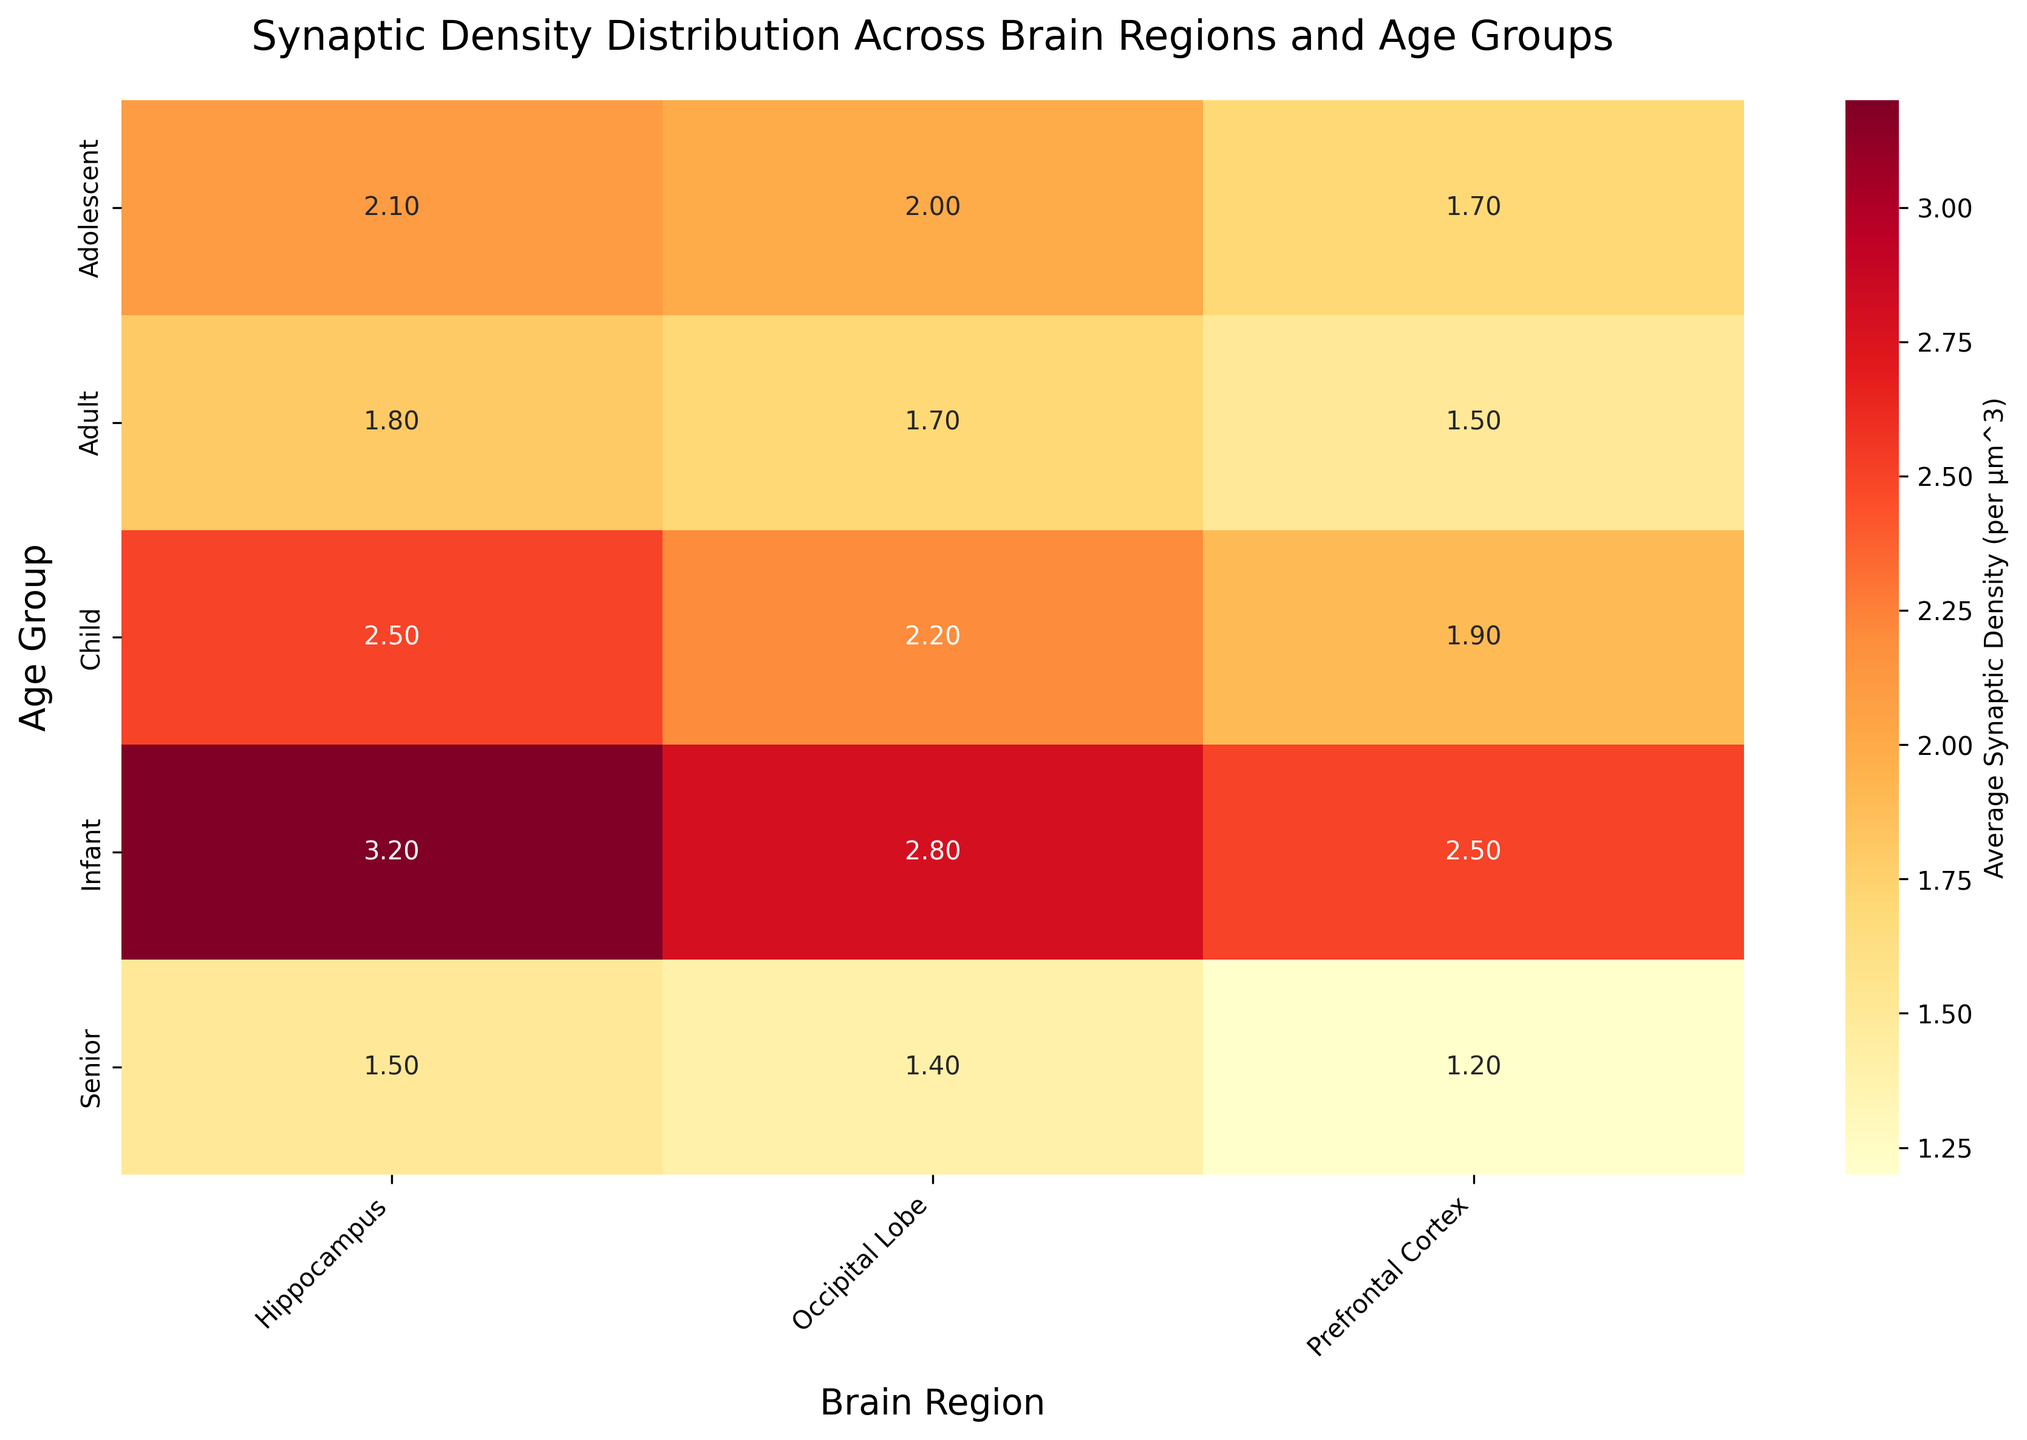What age group and brain region have the highest average synaptic density? The heatmap shows the average synaptic densities across different brain regions and age groups. The cell with the brightest color in the heatmap corresponds to the highest value. By examining the figure, we see that the brightest cell is in the Infant age group and Hippocampus region, indicating the highest average synaptic density.
Answer: Infant in the Hippocampus What is the title of the heatmap? The title is usually displayed at the top of the figure. It is used to give an overview of what the plotted data represents. For this heatmap, the title is displayed clearly.
Answer: Synaptic Density Distribution Across Brain Regions and Age Groups Which age group has the lowest synaptic density in the Prefrontal Cortex? Looking at the Prefrontal Cortex column in the heatmap and identifying the cell with the darkest shade will give us the lowest value. The Senior age group has the darkest cell in this column, indicating the lowest synaptic density.
Answer: Senior What is the difference in average synaptic density between the Infant and Adult groups in the Prefrontal Cortex? To find the difference, locate the values for the Infant and Adult age groups in the Prefrontal Cortex column. Subtract the Adult value from the Infant value (2.5 - 1.5).
Answer: 1.0 Which brain region has the most stable synaptic density across all age groups? Stability refers to minimal variation across age groups. By scanning each column and observing the color gradients, the Occipital Lobe shows the least color variation, indicating more stable synaptic density across all age groups.
Answer: Occipital Lobe What's the average synaptic density in the Hippocampus for Adolescent age group? Find the cell in the Hippocampus column and Adolescent row, which is annotated with the value.
Answer: 2.1 Compare the synaptic density in the Hippocampus for Child and Adult age groups. Which has a higher value? Look at the Hippocampus column and compare the Child (2.5) and Adult (1.8) values directly. Child has a higher value.
Answer: Child What is the sum of the average synaptic densities in the Occipital Lobe for all age groups? Locate the values in the Occipital Lobe column and add them together (2.8 + 2.2 + 2.0 + 1.7 + 1.4).
Answer: 10.1 Which brain region shows the most significant decline in synaptic density from Infant to Senior age group? Calculate the decline by subtracting the value for the Senior group from the Infant group for each brain region. The Prefrontal Cortex has the most significant decline (2.5 - 1.2 = 1.3).
Answer: Prefrontal Cortex 